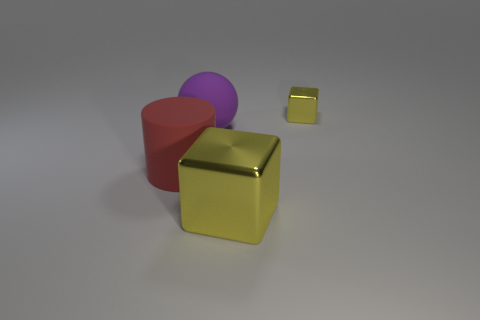Add 3 red matte cylinders. How many objects exist? 7 Subtract all cylinders. How many objects are left? 3 Add 4 purple rubber balls. How many purple rubber balls exist? 5 Subtract 0 cyan balls. How many objects are left? 4 Subtract all large red cylinders. Subtract all purple spheres. How many objects are left? 2 Add 3 big objects. How many big objects are left? 6 